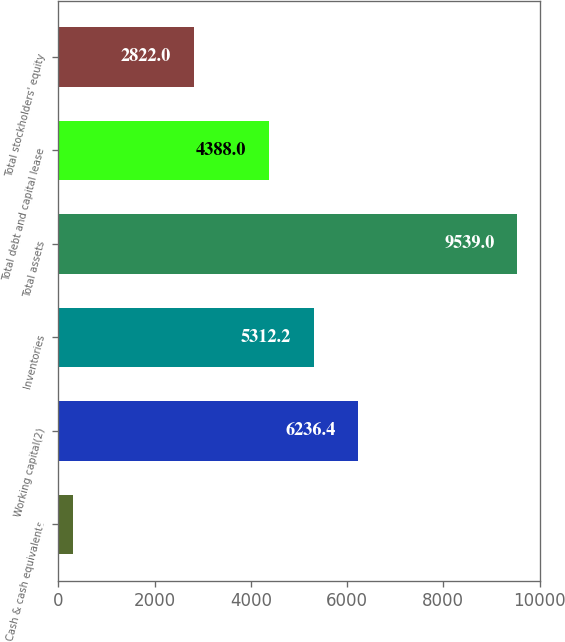Convert chart to OTSL. <chart><loc_0><loc_0><loc_500><loc_500><bar_chart><fcel>Cash & cash equivalents<fcel>Working capital(2)<fcel>Inventories<fcel>Total assets<fcel>Total debt and capital lease<fcel>Total stockholders' equity<nl><fcel>297<fcel>6236.4<fcel>5312.2<fcel>9539<fcel>4388<fcel>2822<nl></chart> 